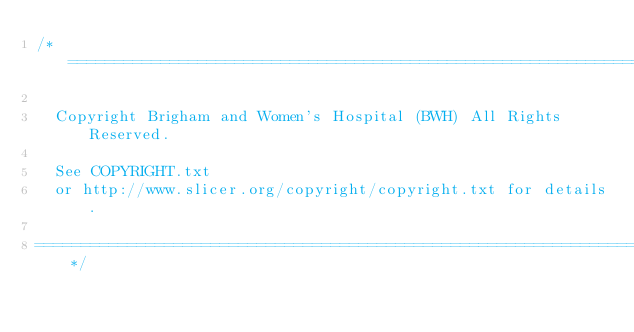<code> <loc_0><loc_0><loc_500><loc_500><_C++_>/*=========================================================================

  Copyright Brigham and Women's Hospital (BWH) All Rights Reserved.

  See COPYRIGHT.txt
  or http://www.slicer.org/copyright/copyright.txt for details.

==========================================================================*/
</code> 